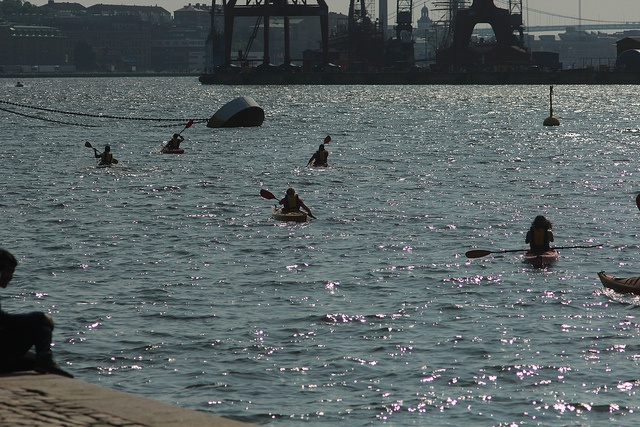Describe the objects in this image and their specific colors. I can see boat in gray, black, darkgray, and purple tones, people in gray, black, and purple tones, people in gray, black, and darkgray tones, boat in gray, black, and maroon tones, and boat in gray and black tones in this image. 